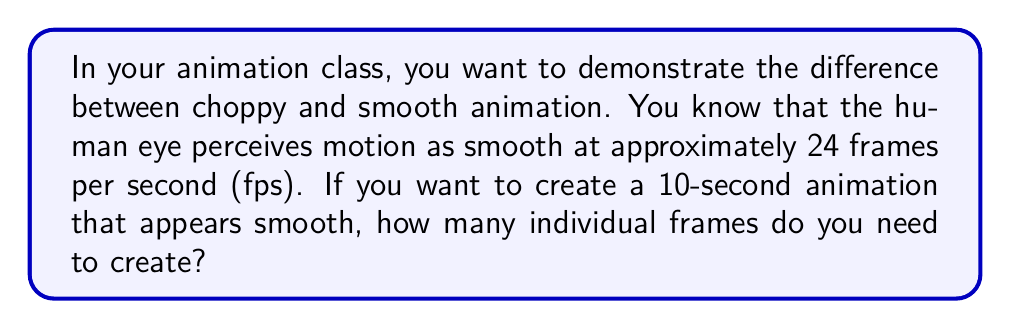Could you help me with this problem? To solve this problem, we need to follow these steps:

1. Identify the given information:
   - Smooth animation requires approximately 24 frames per second (fps)
   - The animation duration is 10 seconds

2. Set up the equation to calculate the total number of frames:
   Let $F$ be the total number of frames
   Let $R$ be the frame rate in fps
   Let $T$ be the duration in seconds

   $$F = R \times T$$

3. Substitute the known values:
   $$F = 24 \text{ fps} \times 10 \text{ seconds}$$

4. Perform the multiplication:
   $$F = 240 \text{ frames}$$

Therefore, to create a 10-second animation that appears smooth, you need to create 240 individual frames.
Answer: 240 frames 